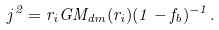Convert formula to latex. <formula><loc_0><loc_0><loc_500><loc_500>j ^ { 2 } = r _ { i } G M _ { d m } ( r _ { i } ) ( 1 - f _ { b } ) ^ { - 1 } .</formula> 